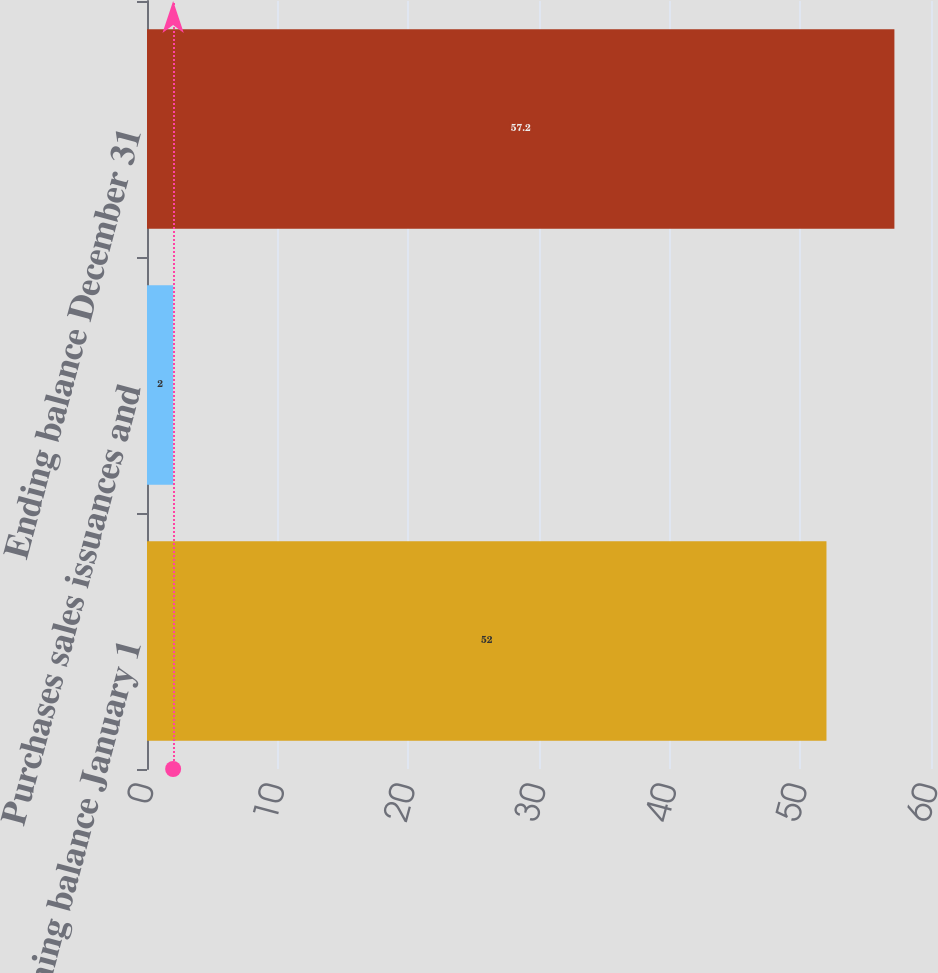Convert chart to OTSL. <chart><loc_0><loc_0><loc_500><loc_500><bar_chart><fcel>Beginning balance January 1<fcel>Purchases sales issuances and<fcel>Ending balance December 31<nl><fcel>52<fcel>2<fcel>57.2<nl></chart> 